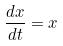Convert formula to latex. <formula><loc_0><loc_0><loc_500><loc_500>\frac { d x } { d t } = x</formula> 